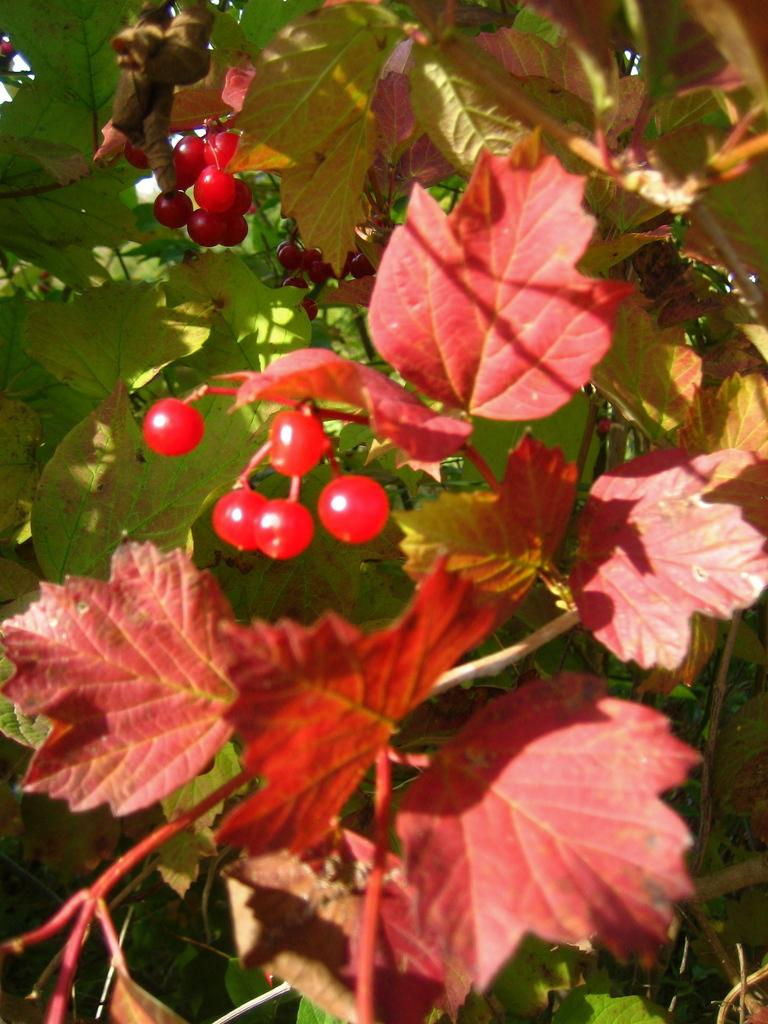What type of living organisms are present in the image? There are plants in the image. What specific parts of the plants can be seen? The plants have leaves and fruits. What type of curve can be seen in the image? There is no curve present in the image; it features plants with leaves and fruits. How much honey is being produced by the plants in the image? There is no honey production mentioned or visible in the image, as it features plants with leaves and fruits. 